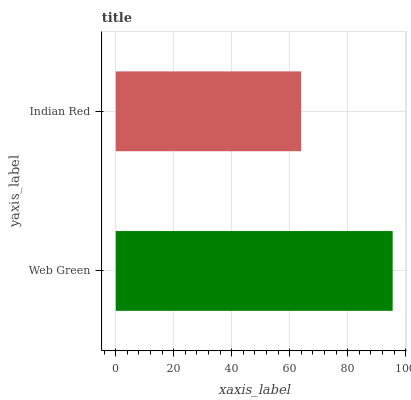Is Indian Red the minimum?
Answer yes or no. Yes. Is Web Green the maximum?
Answer yes or no. Yes. Is Indian Red the maximum?
Answer yes or no. No. Is Web Green greater than Indian Red?
Answer yes or no. Yes. Is Indian Red less than Web Green?
Answer yes or no. Yes. Is Indian Red greater than Web Green?
Answer yes or no. No. Is Web Green less than Indian Red?
Answer yes or no. No. Is Web Green the high median?
Answer yes or no. Yes. Is Indian Red the low median?
Answer yes or no. Yes. Is Indian Red the high median?
Answer yes or no. No. Is Web Green the low median?
Answer yes or no. No. 